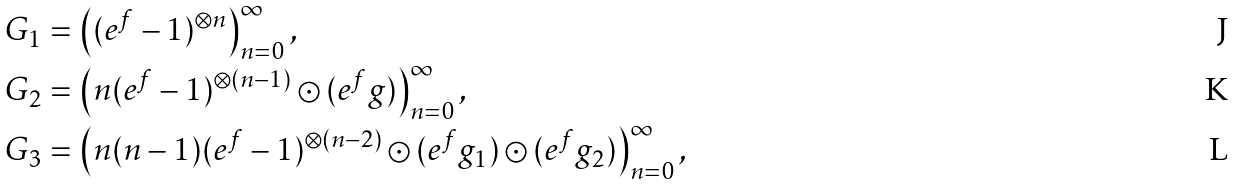Convert formula to latex. <formula><loc_0><loc_0><loc_500><loc_500>G _ { 1 } & = \left ( ( e ^ { f } - 1 ) ^ { \otimes n } \right ) _ { n = 0 } ^ { \infty } , \\ G _ { 2 } & = \left ( n ( e ^ { f } - 1 ) ^ { \otimes ( n - 1 ) } \odot ( e ^ { f } g ) \right ) _ { n = 0 } ^ { \infty } , \\ G _ { 3 } & = \left ( n ( n - 1 ) ( e ^ { f } - 1 ) ^ { \otimes ( n - 2 ) } \odot ( e ^ { f } g _ { 1 } ) \odot ( e ^ { f } g _ { 2 } ) \right ) _ { n = 0 } ^ { \infty } ,</formula> 